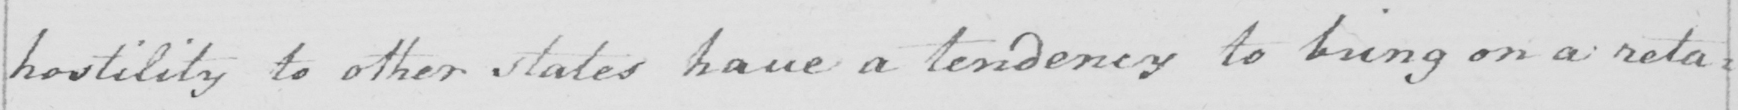Please transcribe the handwritten text in this image. hostility to other states have a tendency to bring on a reta= 